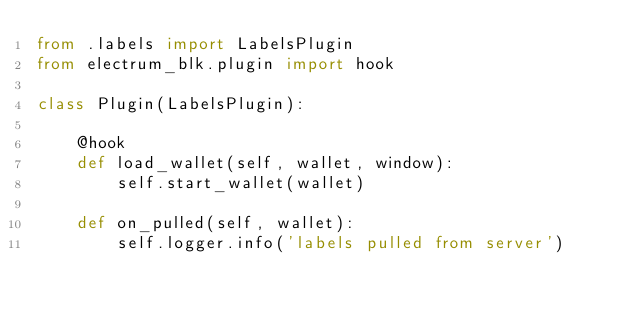<code> <loc_0><loc_0><loc_500><loc_500><_Python_>from .labels import LabelsPlugin
from electrum_blk.plugin import hook

class Plugin(LabelsPlugin):

    @hook
    def load_wallet(self, wallet, window):
        self.start_wallet(wallet)

    def on_pulled(self, wallet):
        self.logger.info('labels pulled from server')
</code> 